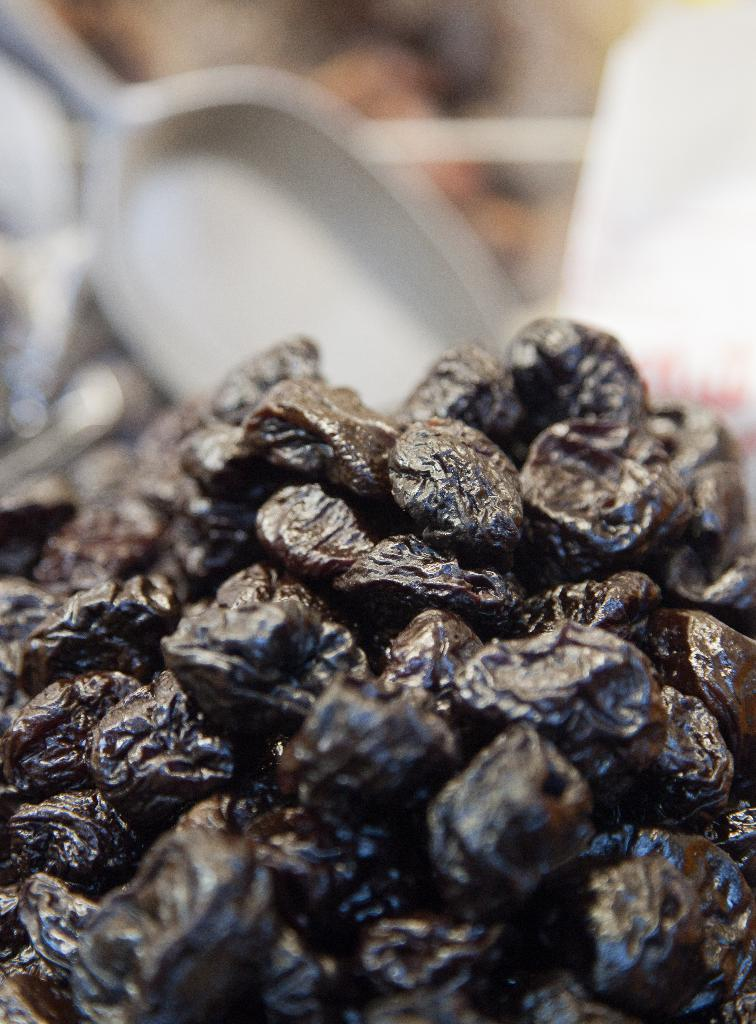What type of food is featured in the image? There is a cluster of black dates in the image. What object is visible in the background of the image? There is a serving spoon in the background of the image. What historical discovery is depicted in the image? There is no historical discovery depicted in the image; it features a cluster of black dates and a serving spoon. What does the queen have to do with the image? There is no reference to a queen in the image or the provided facts. 